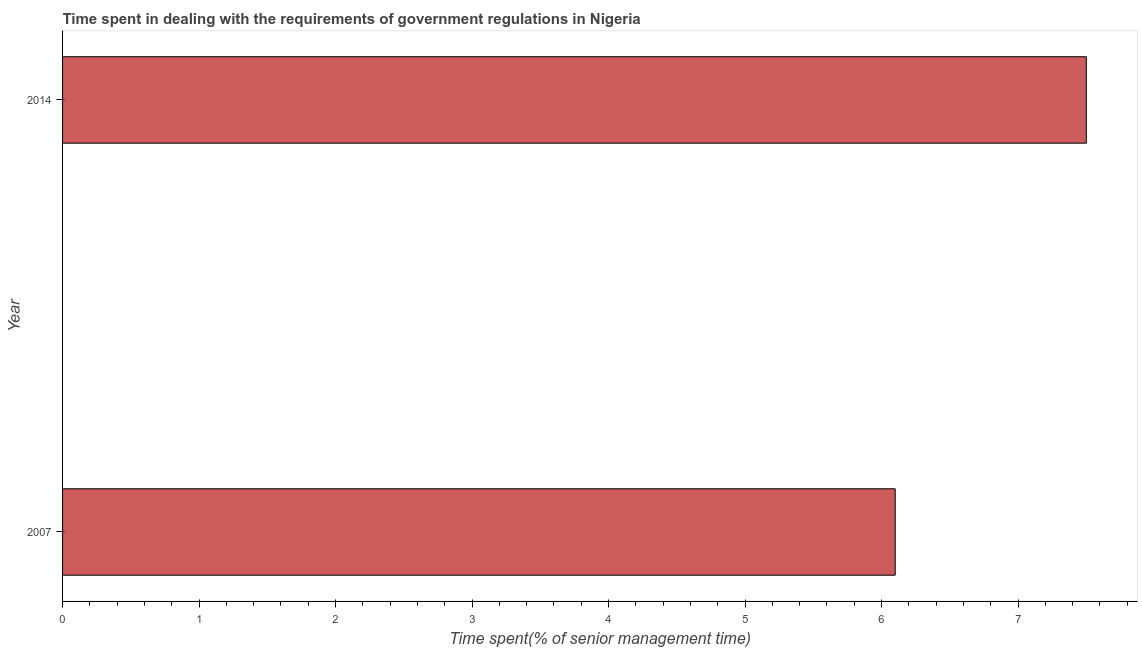What is the title of the graph?
Keep it short and to the point. Time spent in dealing with the requirements of government regulations in Nigeria. What is the label or title of the X-axis?
Your response must be concise. Time spent(% of senior management time). What is the time spent in dealing with government regulations in 2014?
Ensure brevity in your answer.  7.5. Across all years, what is the maximum time spent in dealing with government regulations?
Offer a terse response. 7.5. What is the difference between the time spent in dealing with government regulations in 2007 and 2014?
Your answer should be compact. -1.4. What is the average time spent in dealing with government regulations per year?
Your answer should be compact. 6.8. In how many years, is the time spent in dealing with government regulations greater than 1.4 %?
Provide a short and direct response. 2. Do a majority of the years between 2014 and 2007 (inclusive) have time spent in dealing with government regulations greater than 2.8 %?
Ensure brevity in your answer.  No. What is the ratio of the time spent in dealing with government regulations in 2007 to that in 2014?
Your response must be concise. 0.81. Is the time spent in dealing with government regulations in 2007 less than that in 2014?
Make the answer very short. Yes. What is the Time spent(% of senior management time) of 2007?
Offer a terse response. 6.1. What is the Time spent(% of senior management time) in 2014?
Give a very brief answer. 7.5. What is the difference between the Time spent(% of senior management time) in 2007 and 2014?
Offer a very short reply. -1.4. What is the ratio of the Time spent(% of senior management time) in 2007 to that in 2014?
Keep it short and to the point. 0.81. 